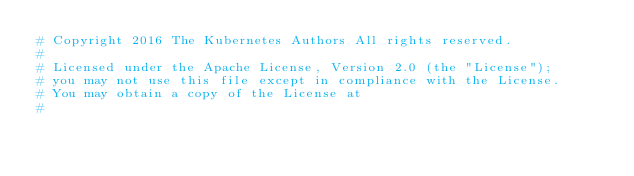<code> <loc_0><loc_0><loc_500><loc_500><_YAML_># Copyright 2016 The Kubernetes Authors All rights reserved.
#
# Licensed under the Apache License, Version 2.0 (the "License");
# you may not use this file except in compliance with the License.
# You may obtain a copy of the License at
#</code> 